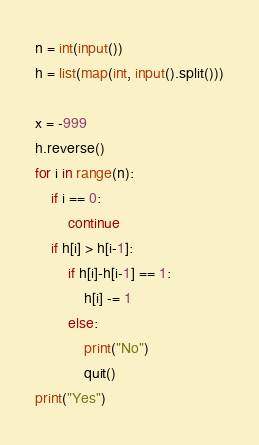Convert code to text. <code><loc_0><loc_0><loc_500><loc_500><_Python_>n = int(input())
h = list(map(int, input().split()))

x = -999
h.reverse()
for i in range(n):
    if i == 0:
        continue
    if h[i] > h[i-1]:
        if h[i]-h[i-1] == 1:
            h[i] -= 1
        else:
            print("No")
            quit()
print("Yes")</code> 